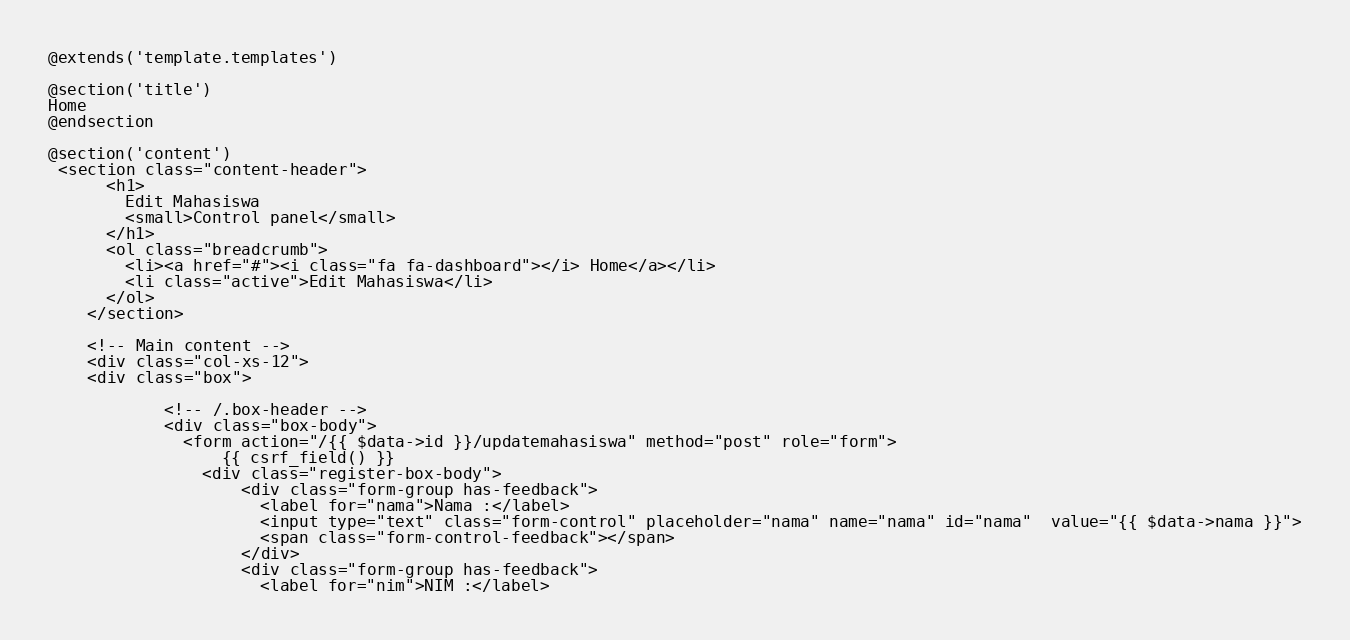<code> <loc_0><loc_0><loc_500><loc_500><_PHP_>@extends('template.templates')

@section('title')
Home
@endsection

@section('content')
 <section class="content-header">
      <h1>
        Edit Mahasiswa
        <small>Control panel</small>
      </h1>
      <ol class="breadcrumb">
        <li><a href="#"><i class="fa fa-dashboard"></i> Home</a></li>
        <li class="active">Edit Mahasiswa</li>
      </ol>
    </section>

    <!-- Main content -->
    <div class="col-xs-12">
    <div class="box">

            <!-- /.box-header -->
            <div class="box-body">
              <form action="/{{ $data->id }}/updatemahasiswa" method="post" role="form">
                  {{ csrf_field() }}
                <div class="register-box-body">
                    <div class="form-group has-feedback">
                      <label for="nama">Nama :</label>
                      <input type="text" class="form-control" placeholder="nama" name="nama" id="nama"  value="{{ $data->nama }}">
                      <span class="form-control-feedback"></span>
                    </div>
                    <div class="form-group has-feedback">
                      <label for="nim">NIM :</label></code> 